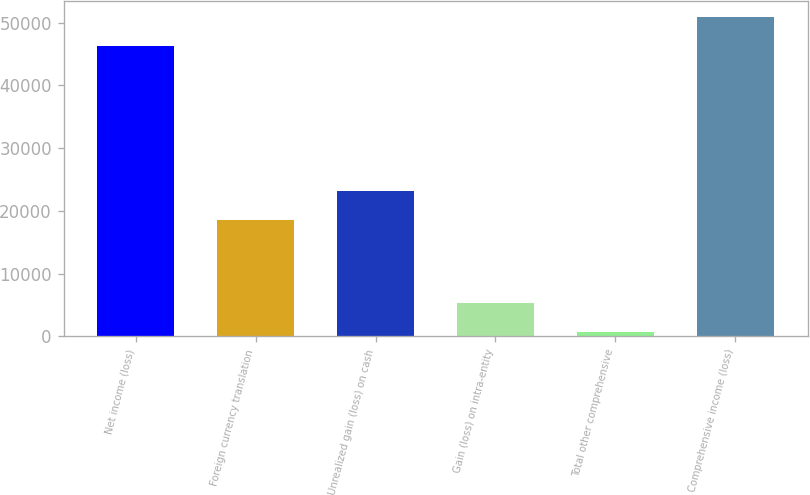<chart> <loc_0><loc_0><loc_500><loc_500><bar_chart><fcel>Net income (loss)<fcel>Foreign currency translation<fcel>Unrealized gain (loss) on cash<fcel>Gain (loss) on intra-entity<fcel>Total other comprehensive<fcel>Comprehensive income (loss)<nl><fcel>46302<fcel>18535<fcel>23165.2<fcel>5406.2<fcel>776<fcel>50932.2<nl></chart> 